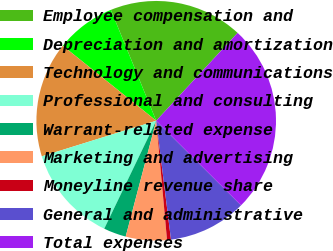Convert chart to OTSL. <chart><loc_0><loc_0><loc_500><loc_500><pie_chart><fcel>Employee compensation and<fcel>Depreciation and amortization<fcel>Technology and communications<fcel>Professional and consulting<fcel>Warrant-related expense<fcel>Marketing and advertising<fcel>Moneyline revenue share<fcel>General and administrative<fcel>Total expenses<nl><fcel>18.07%<fcel>8.05%<fcel>15.57%<fcel>13.06%<fcel>3.04%<fcel>5.54%<fcel>0.53%<fcel>10.55%<fcel>25.59%<nl></chart> 